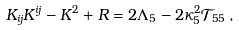Convert formula to latex. <formula><loc_0><loc_0><loc_500><loc_500>K _ { i j } K ^ { i j } - K ^ { 2 } + R = 2 \Lambda _ { 5 } - 2 \kappa _ { 5 } ^ { 2 } \mathcal { T } _ { 5 5 } \, ,</formula> 